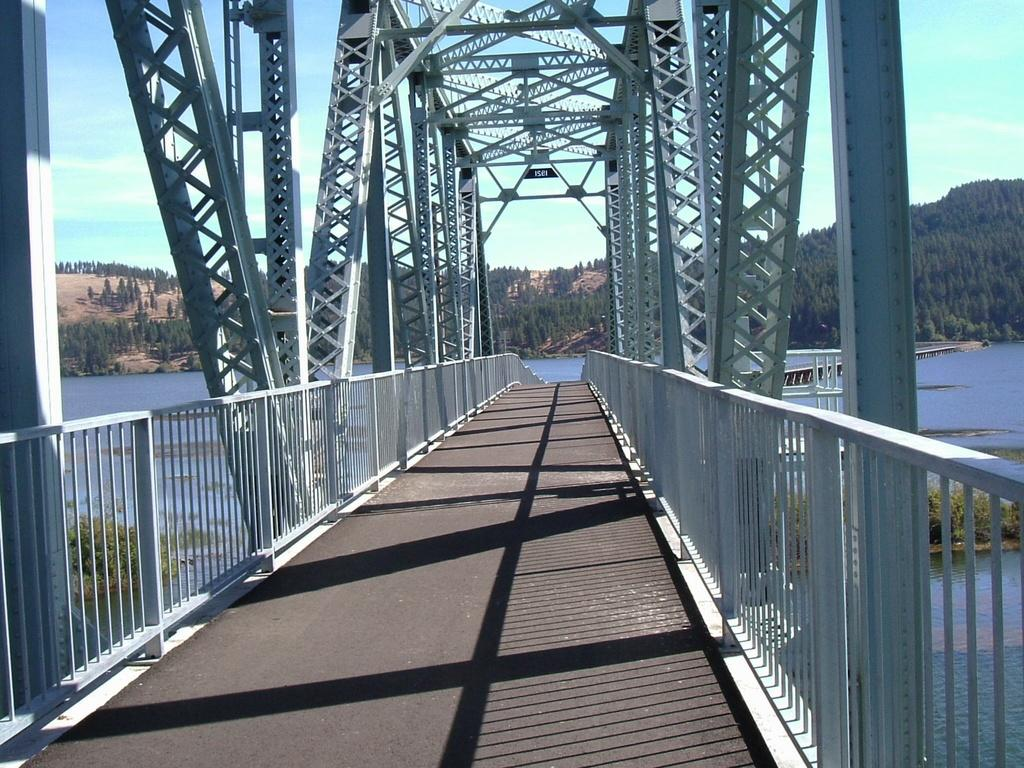What type of structure can be seen in the image? There is a bridge in the image. What type of vegetation is present in the image? There are trees in the image. What natural element is visible in the image? Water is visible in the image. What part of the natural environment is visible in the image? The sky is visible in the image. What type of crime is being committed on the bridge in the image? There is no crime being committed in the image; it only shows a bridge, trees, water, and the sky. 